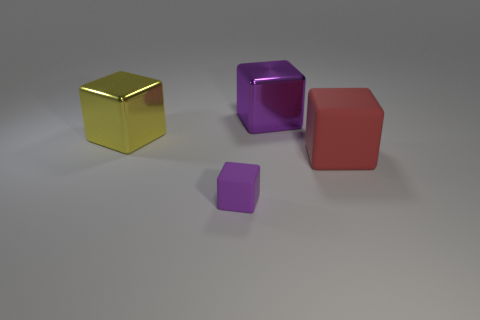What number of metallic things are the same color as the small matte cube?
Offer a very short reply. 1. How many other things are the same color as the small cube?
Ensure brevity in your answer.  1. There is another object that is the same color as the small matte object; what shape is it?
Offer a terse response. Cube. What number of red matte blocks have the same size as the yellow thing?
Make the answer very short. 1. There is a metallic cube that is the same color as the small rubber block; what size is it?
Provide a short and direct response. Large. How many objects are either large matte blocks or metal things that are to the left of the purple metal cube?
Give a very brief answer. 2. The thing that is both to the right of the large yellow metallic object and behind the red thing is what color?
Your answer should be very brief. Purple. Do the purple shiny thing and the purple matte thing have the same size?
Your response must be concise. No. The large metal thing that is in front of the big purple block is what color?
Your answer should be compact. Yellow. Are there any tiny balls of the same color as the tiny matte block?
Offer a very short reply. No. 